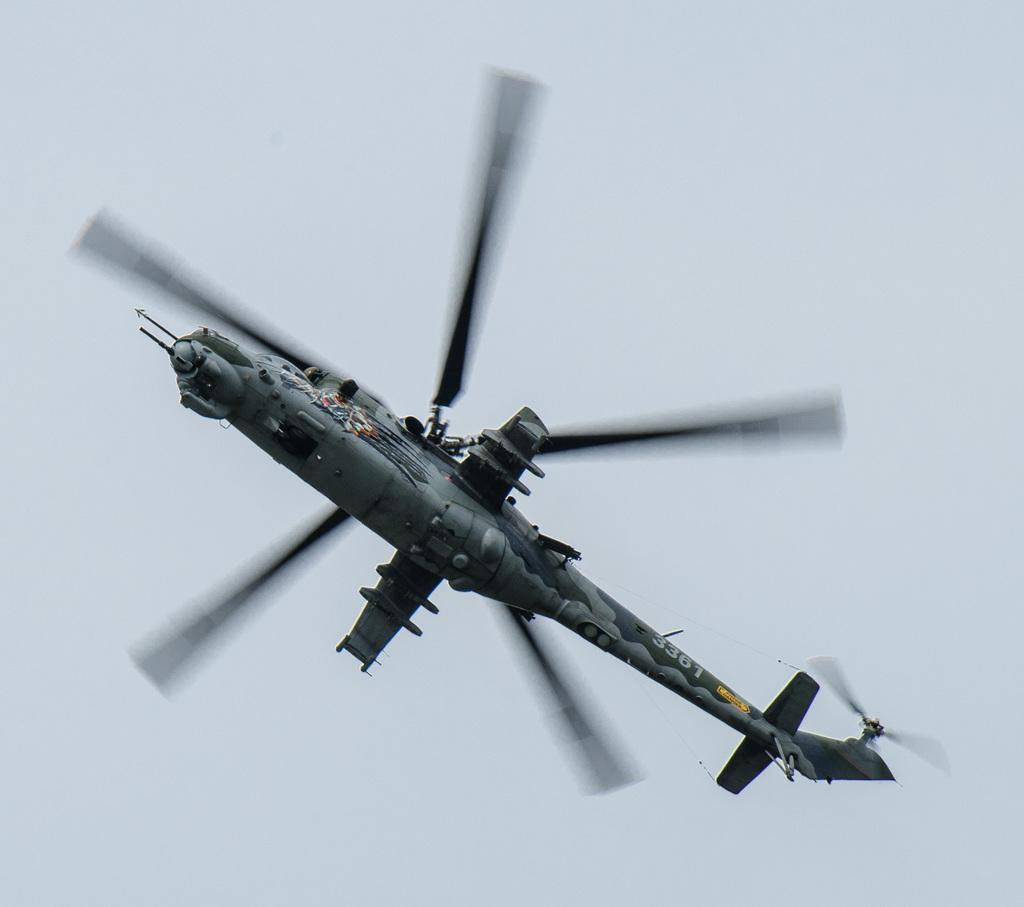What is the main subject of the image? The main subject of the image is a helicopter. What is the helicopter doing in the image? The helicopter is flying in the air. What can be seen in the background of the image? The sky is visible in the background of the image. What type of linen is being used to cover the helicopter in the image? There is no linen present in the image, and the helicopter is not covered. How many chains are attached to the helicopter in the image? There are no chains attached to the helicopter in the image. 